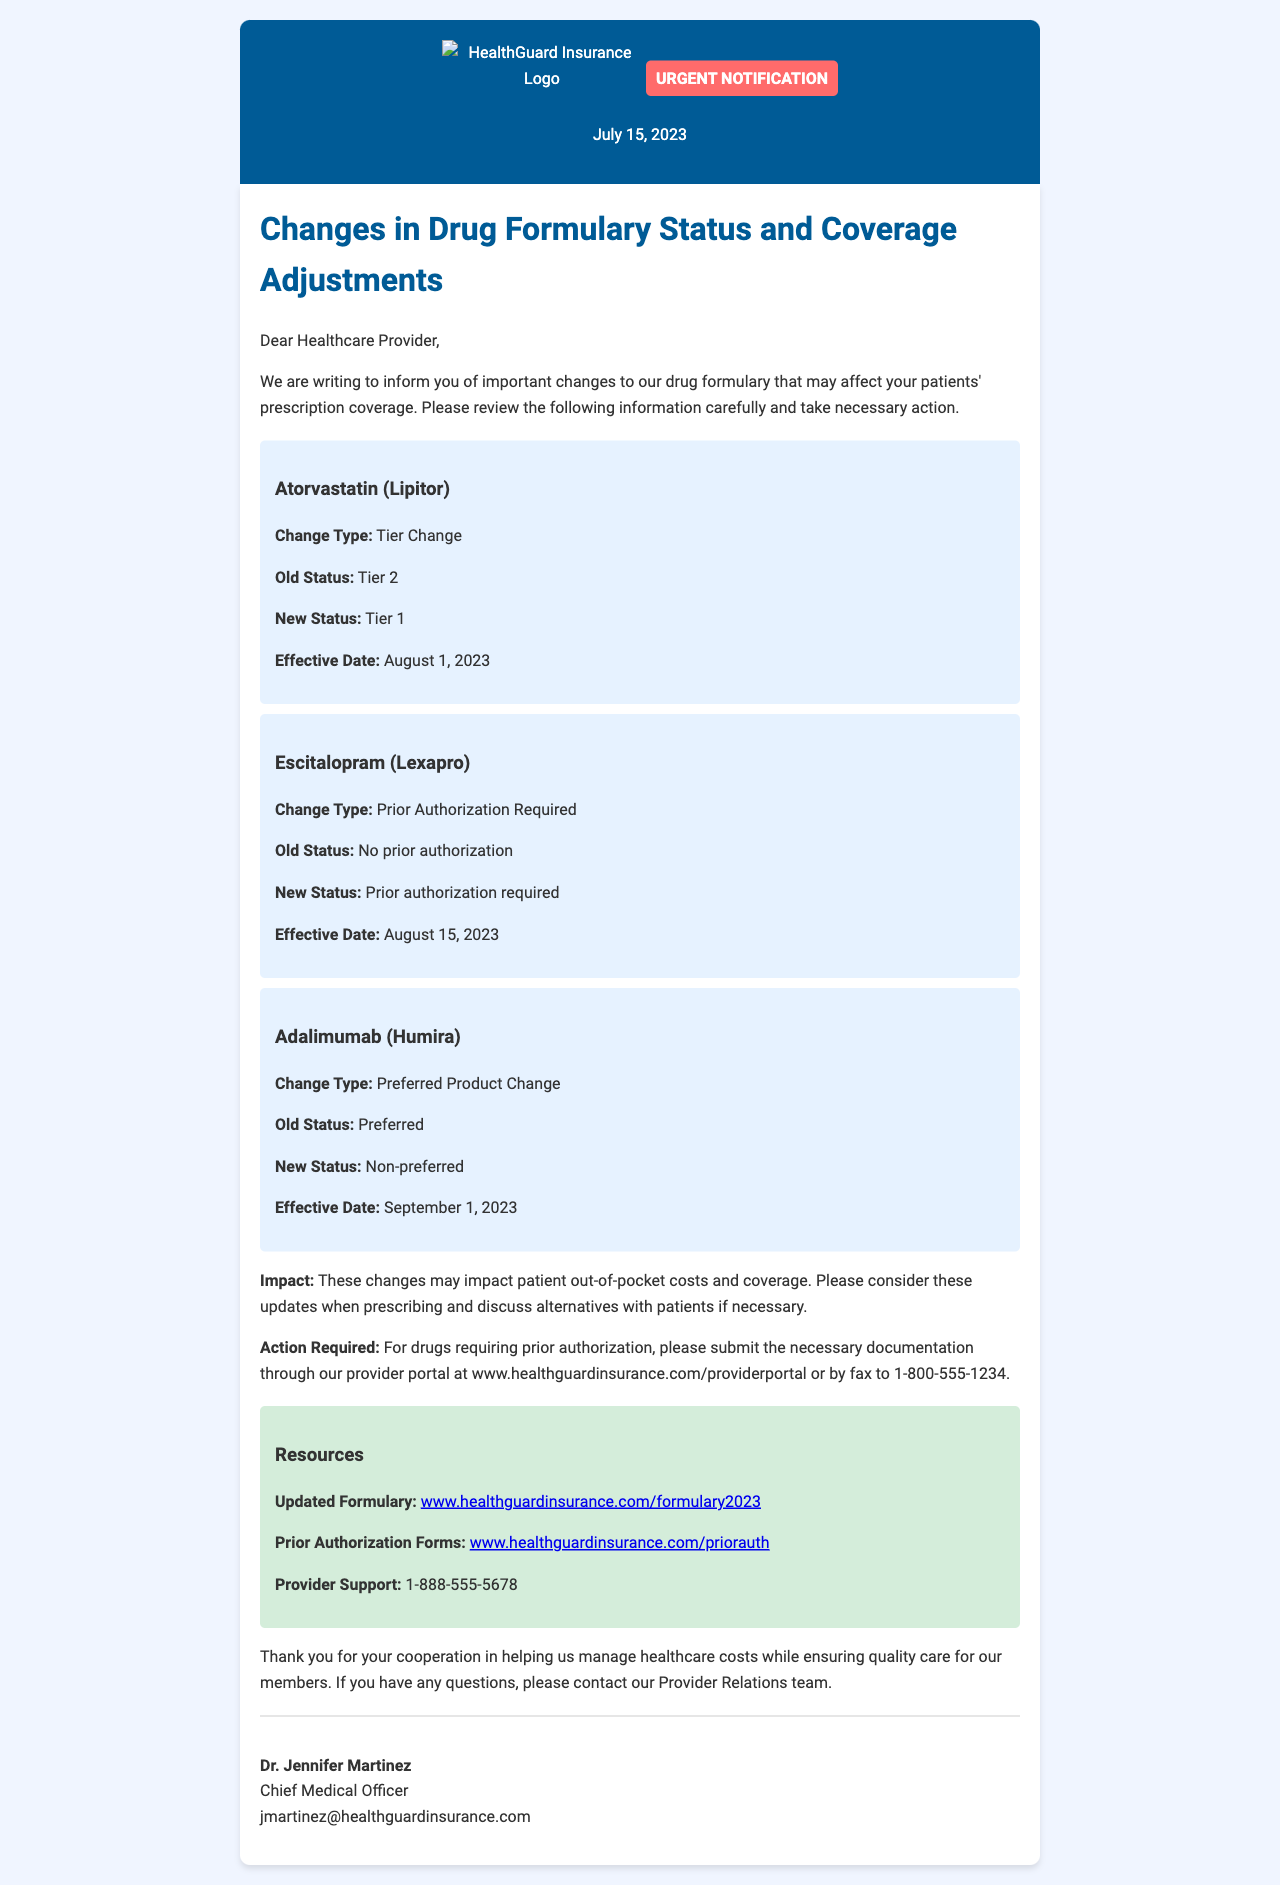What is the effective date for Atorvastatin (Lipitor)? The effective date for Atorvastatin (Lipitor) is mentioned in the document, stating it as August 1, 2023.
Answer: August 1, 2023 What is the new status of Escitalopram (Lexapro)? The document specifies that the new status of Escitalopram (Lexapro) is prior authorization required.
Answer: Prior authorization required What type of change is noted for Adalimumab (Humira)? The document describes the type of change for Adalimumab (Humira) as a Preferred Product Change.
Answer: Preferred Product Change Who is the Chief Medical Officer? The document lists Dr. Jennifer Martinez as the Chief Medical Officer.
Answer: Dr. Jennifer Martinez What is the provider support contact number? The document provides a contact number for provider support, which is 1-888-555-5678.
Answer: 1-888-555-5678 What action is required for drugs requiring prior authorization? The document instructs providers to submit necessary documentation through their provider portal or by fax.
Answer: Submit documentation Which drug changes to Tier 1 status? The document indicates that Atorvastatin (Lipitor) changes to Tier 1 status.
Answer: Atorvastatin (Lipitor) What website provides the updated formulary? The document refers to the website for the updated formulary as www.healthguardinsurance.com/formulary2023.
Answer: www.healthguardinsurance.com/formulary2023 